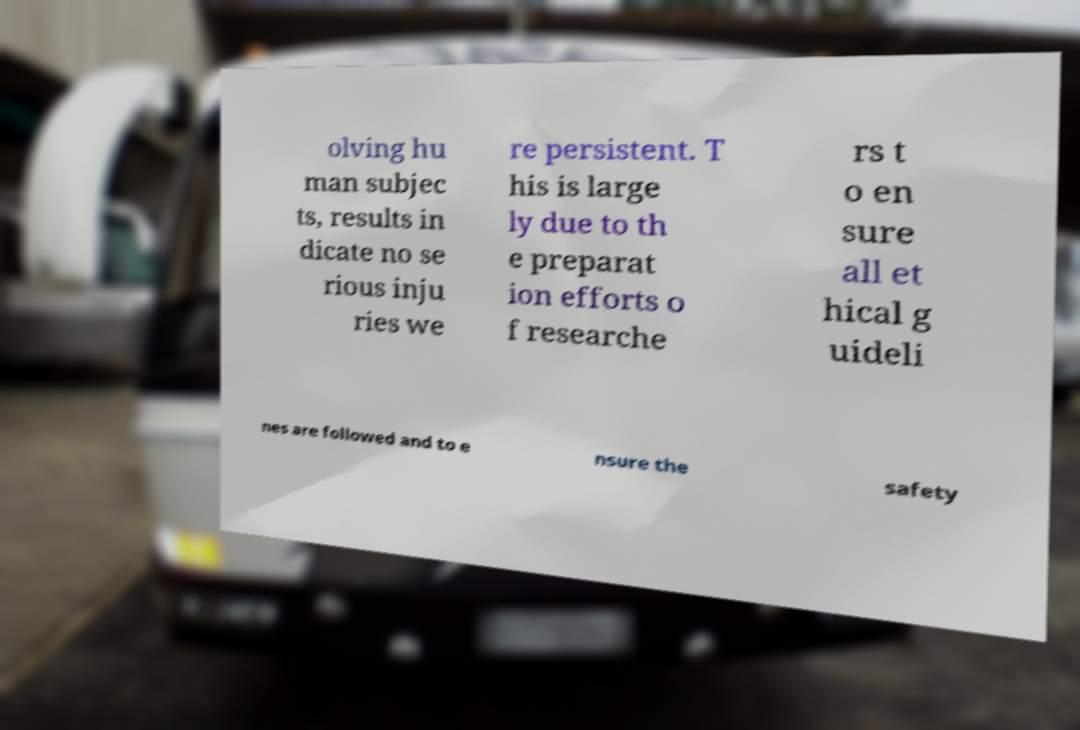For documentation purposes, I need the text within this image transcribed. Could you provide that? olving hu man subjec ts, results in dicate no se rious inju ries we re persistent. T his is large ly due to th e preparat ion efforts o f researche rs t o en sure all et hical g uideli nes are followed and to e nsure the safety 